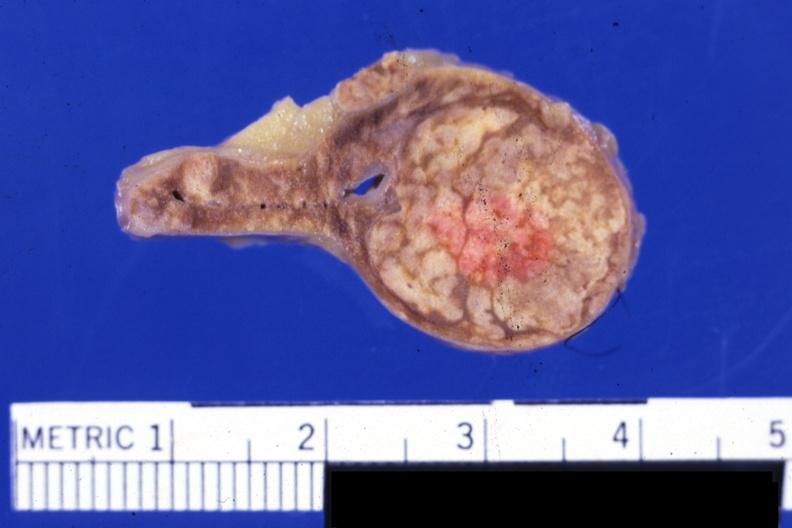what is present?
Answer the question using a single word or phrase. Adrenal 